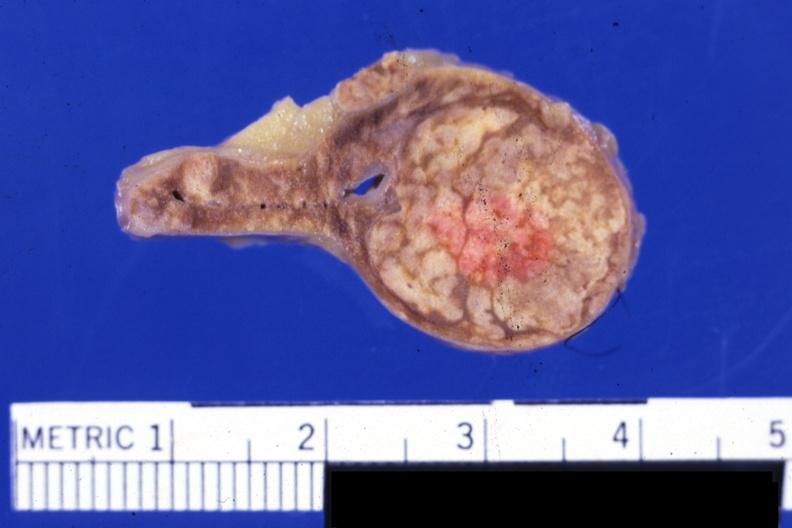what is present?
Answer the question using a single word or phrase. Adrenal 